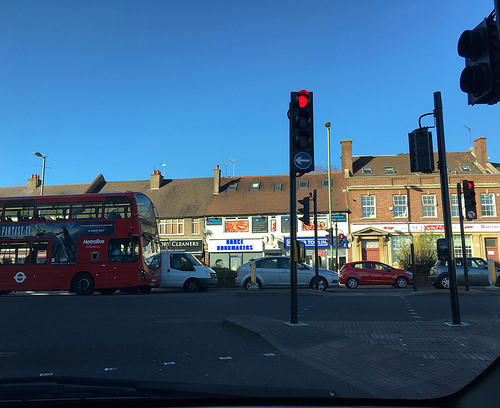<image>
Is there a traffic light behind the car? No. The traffic light is not behind the car. From this viewpoint, the traffic light appears to be positioned elsewhere in the scene. Is the van behind the bus? No. The van is not behind the bus. From this viewpoint, the van appears to be positioned elsewhere in the scene. 